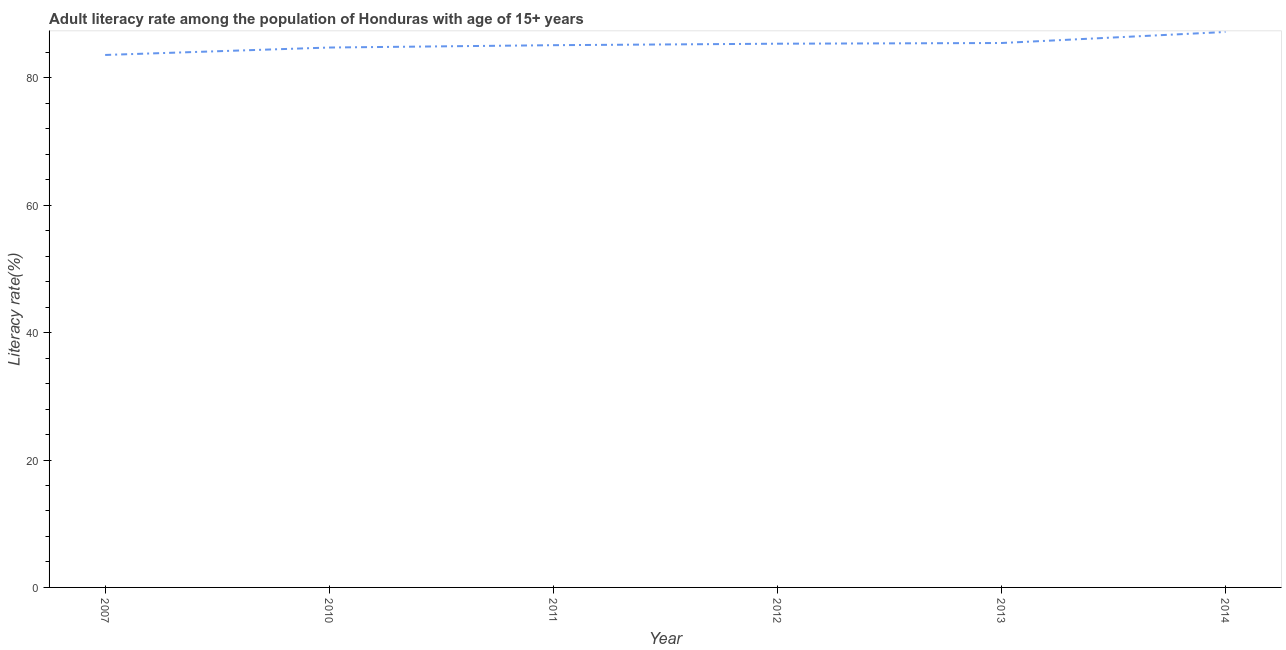What is the adult literacy rate in 2011?
Provide a short and direct response. 85.12. Across all years, what is the maximum adult literacy rate?
Provide a succinct answer. 87.2. Across all years, what is the minimum adult literacy rate?
Give a very brief answer. 83.59. What is the sum of the adult literacy rate?
Your answer should be very brief. 511.49. What is the difference between the adult literacy rate in 2007 and 2013?
Offer a very short reply. -1.88. What is the average adult literacy rate per year?
Give a very brief answer. 85.25. What is the median adult literacy rate?
Your response must be concise. 85.24. In how many years, is the adult literacy rate greater than 8 %?
Make the answer very short. 6. Do a majority of the years between 2011 and 2014 (inclusive) have adult literacy rate greater than 56 %?
Your response must be concise. Yes. What is the ratio of the adult literacy rate in 2012 to that in 2013?
Your response must be concise. 1. Is the difference between the adult literacy rate in 2011 and 2014 greater than the difference between any two years?
Offer a very short reply. No. What is the difference between the highest and the second highest adult literacy rate?
Provide a succinct answer. 1.73. What is the difference between the highest and the lowest adult literacy rate?
Offer a terse response. 3.61. How many years are there in the graph?
Your answer should be compact. 6. What is the title of the graph?
Your response must be concise. Adult literacy rate among the population of Honduras with age of 15+ years. What is the label or title of the X-axis?
Your answer should be very brief. Year. What is the label or title of the Y-axis?
Provide a short and direct response. Literacy rate(%). What is the Literacy rate(%) of 2007?
Keep it short and to the point. 83.59. What is the Literacy rate(%) of 2010?
Ensure brevity in your answer.  84.76. What is the Literacy rate(%) in 2011?
Keep it short and to the point. 85.12. What is the Literacy rate(%) in 2012?
Give a very brief answer. 85.36. What is the Literacy rate(%) of 2013?
Make the answer very short. 85.46. What is the Literacy rate(%) of 2014?
Provide a short and direct response. 87.2. What is the difference between the Literacy rate(%) in 2007 and 2010?
Provide a succinct answer. -1.17. What is the difference between the Literacy rate(%) in 2007 and 2011?
Provide a short and direct response. -1.53. What is the difference between the Literacy rate(%) in 2007 and 2012?
Your response must be concise. -1.77. What is the difference between the Literacy rate(%) in 2007 and 2013?
Offer a very short reply. -1.88. What is the difference between the Literacy rate(%) in 2007 and 2014?
Make the answer very short. -3.61. What is the difference between the Literacy rate(%) in 2010 and 2011?
Provide a short and direct response. -0.37. What is the difference between the Literacy rate(%) in 2010 and 2012?
Offer a terse response. -0.6. What is the difference between the Literacy rate(%) in 2010 and 2013?
Your answer should be compact. -0.71. What is the difference between the Literacy rate(%) in 2010 and 2014?
Provide a short and direct response. -2.44. What is the difference between the Literacy rate(%) in 2011 and 2012?
Offer a terse response. -0.23. What is the difference between the Literacy rate(%) in 2011 and 2013?
Give a very brief answer. -0.34. What is the difference between the Literacy rate(%) in 2011 and 2014?
Offer a very short reply. -2.07. What is the difference between the Literacy rate(%) in 2012 and 2013?
Provide a short and direct response. -0.11. What is the difference between the Literacy rate(%) in 2012 and 2014?
Keep it short and to the point. -1.84. What is the difference between the Literacy rate(%) in 2013 and 2014?
Your response must be concise. -1.73. What is the ratio of the Literacy rate(%) in 2007 to that in 2010?
Keep it short and to the point. 0.99. What is the ratio of the Literacy rate(%) in 2007 to that in 2012?
Your answer should be very brief. 0.98. What is the ratio of the Literacy rate(%) in 2007 to that in 2014?
Your response must be concise. 0.96. What is the ratio of the Literacy rate(%) in 2010 to that in 2014?
Ensure brevity in your answer.  0.97. What is the ratio of the Literacy rate(%) in 2011 to that in 2012?
Keep it short and to the point. 1. 